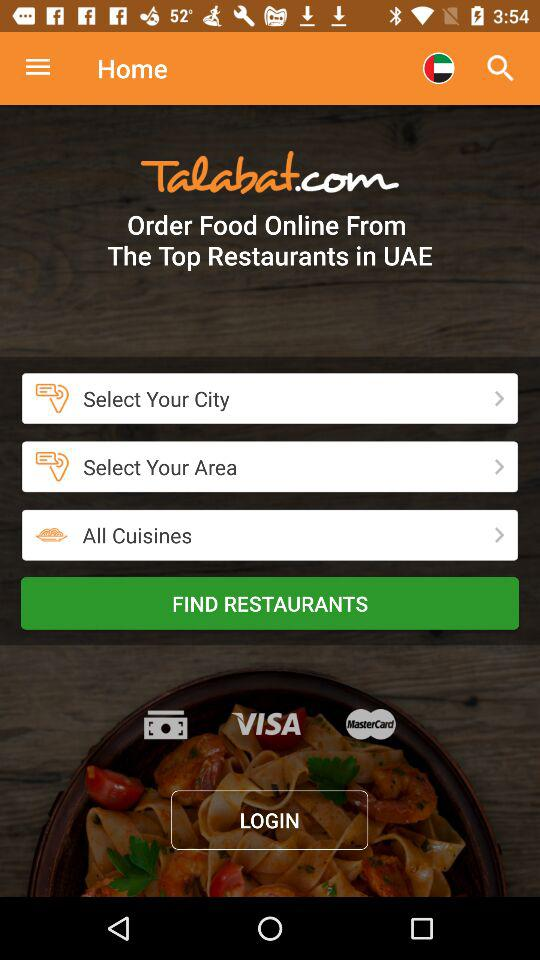What is the application name? The application name is "Talabat.com". 